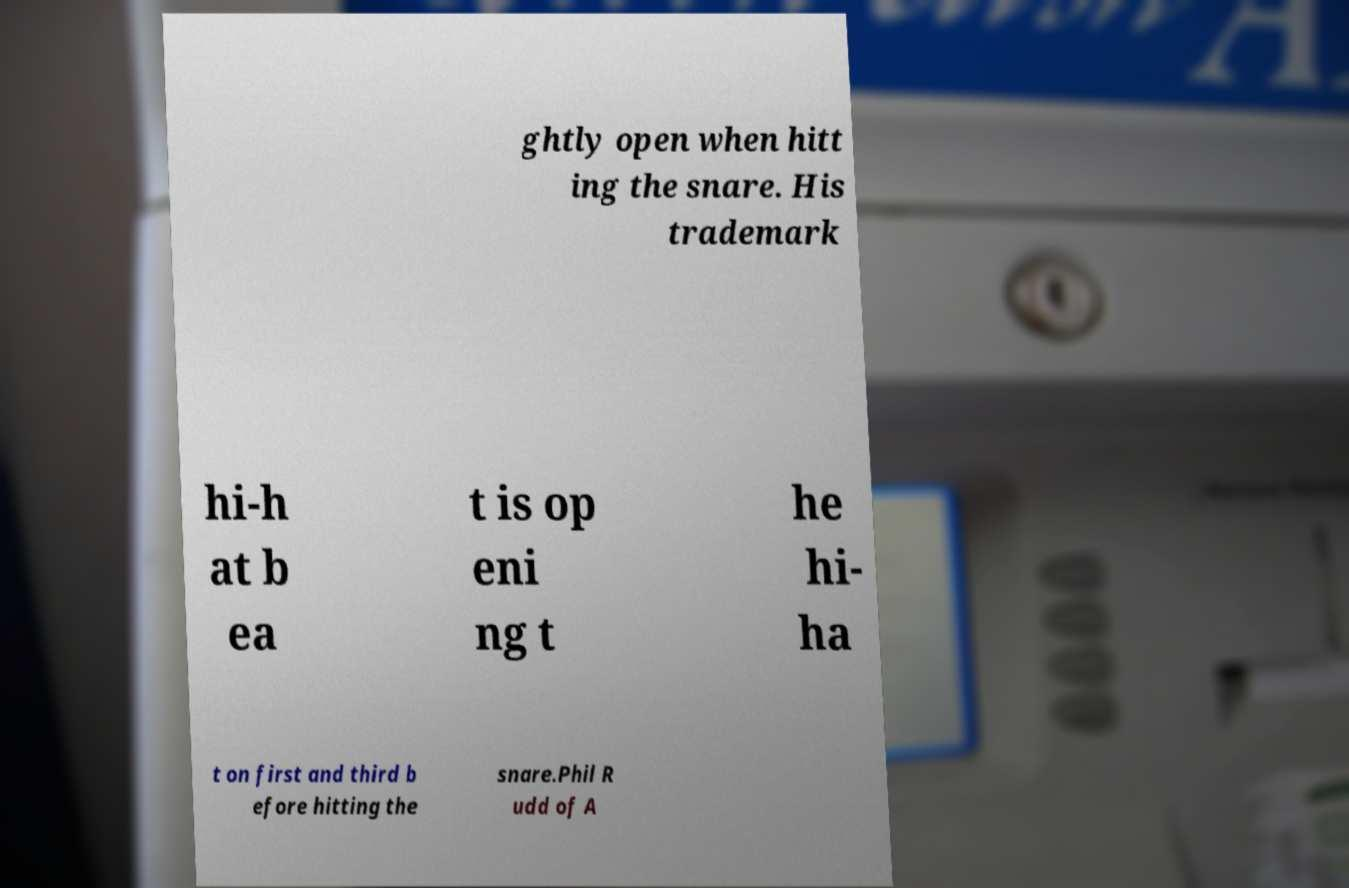Could you assist in decoding the text presented in this image and type it out clearly? ghtly open when hitt ing the snare. His trademark hi-h at b ea t is op eni ng t he hi- ha t on first and third b efore hitting the snare.Phil R udd of A 